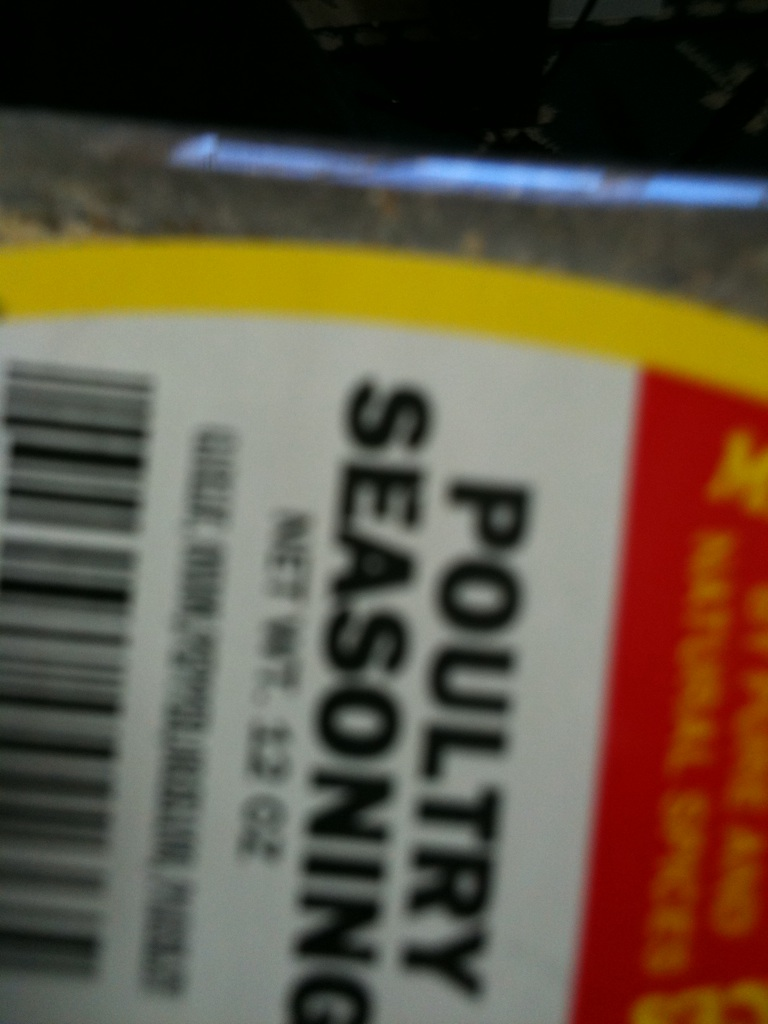What spice is this? The spice captured in the image is poultry seasoning, which is a blend of herbs and spices typically used to enhance the flavor of chicken and other poultry dishes. It often includes ingredients such as sage, thyme, marjoram, rosemary, black pepper, and nutmeg, making it a versatile and aromatic addition to your cooking repertoire. 